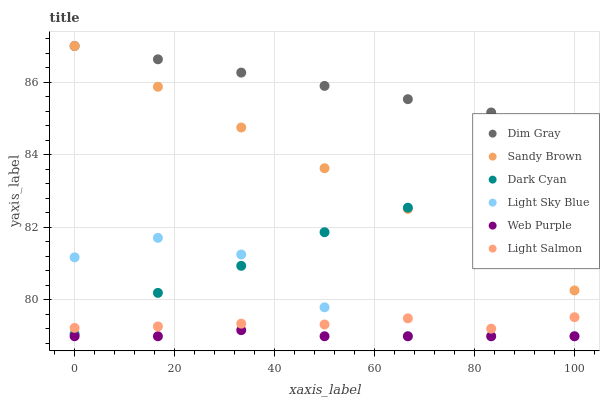Does Web Purple have the minimum area under the curve?
Answer yes or no. Yes. Does Dim Gray have the maximum area under the curve?
Answer yes or no. Yes. Does Dim Gray have the minimum area under the curve?
Answer yes or no. No. Does Web Purple have the maximum area under the curve?
Answer yes or no. No. Is Sandy Brown the smoothest?
Answer yes or no. Yes. Is Light Sky Blue the roughest?
Answer yes or no. Yes. Is Dim Gray the smoothest?
Answer yes or no. No. Is Dim Gray the roughest?
Answer yes or no. No. Does Web Purple have the lowest value?
Answer yes or no. Yes. Does Dim Gray have the lowest value?
Answer yes or no. No. Does Sandy Brown have the highest value?
Answer yes or no. Yes. Does Web Purple have the highest value?
Answer yes or no. No. Is Light Sky Blue less than Dim Gray?
Answer yes or no. Yes. Is Dim Gray greater than Light Salmon?
Answer yes or no. Yes. Does Dark Cyan intersect Sandy Brown?
Answer yes or no. Yes. Is Dark Cyan less than Sandy Brown?
Answer yes or no. No. Is Dark Cyan greater than Sandy Brown?
Answer yes or no. No. Does Light Sky Blue intersect Dim Gray?
Answer yes or no. No. 